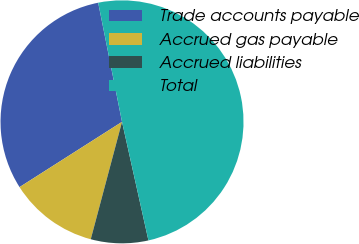<chart> <loc_0><loc_0><loc_500><loc_500><pie_chart><fcel>Trade accounts payable<fcel>Accrued gas payable<fcel>Accrued liabilities<fcel>Total<nl><fcel>30.88%<fcel>11.83%<fcel>7.63%<fcel>49.65%<nl></chart> 